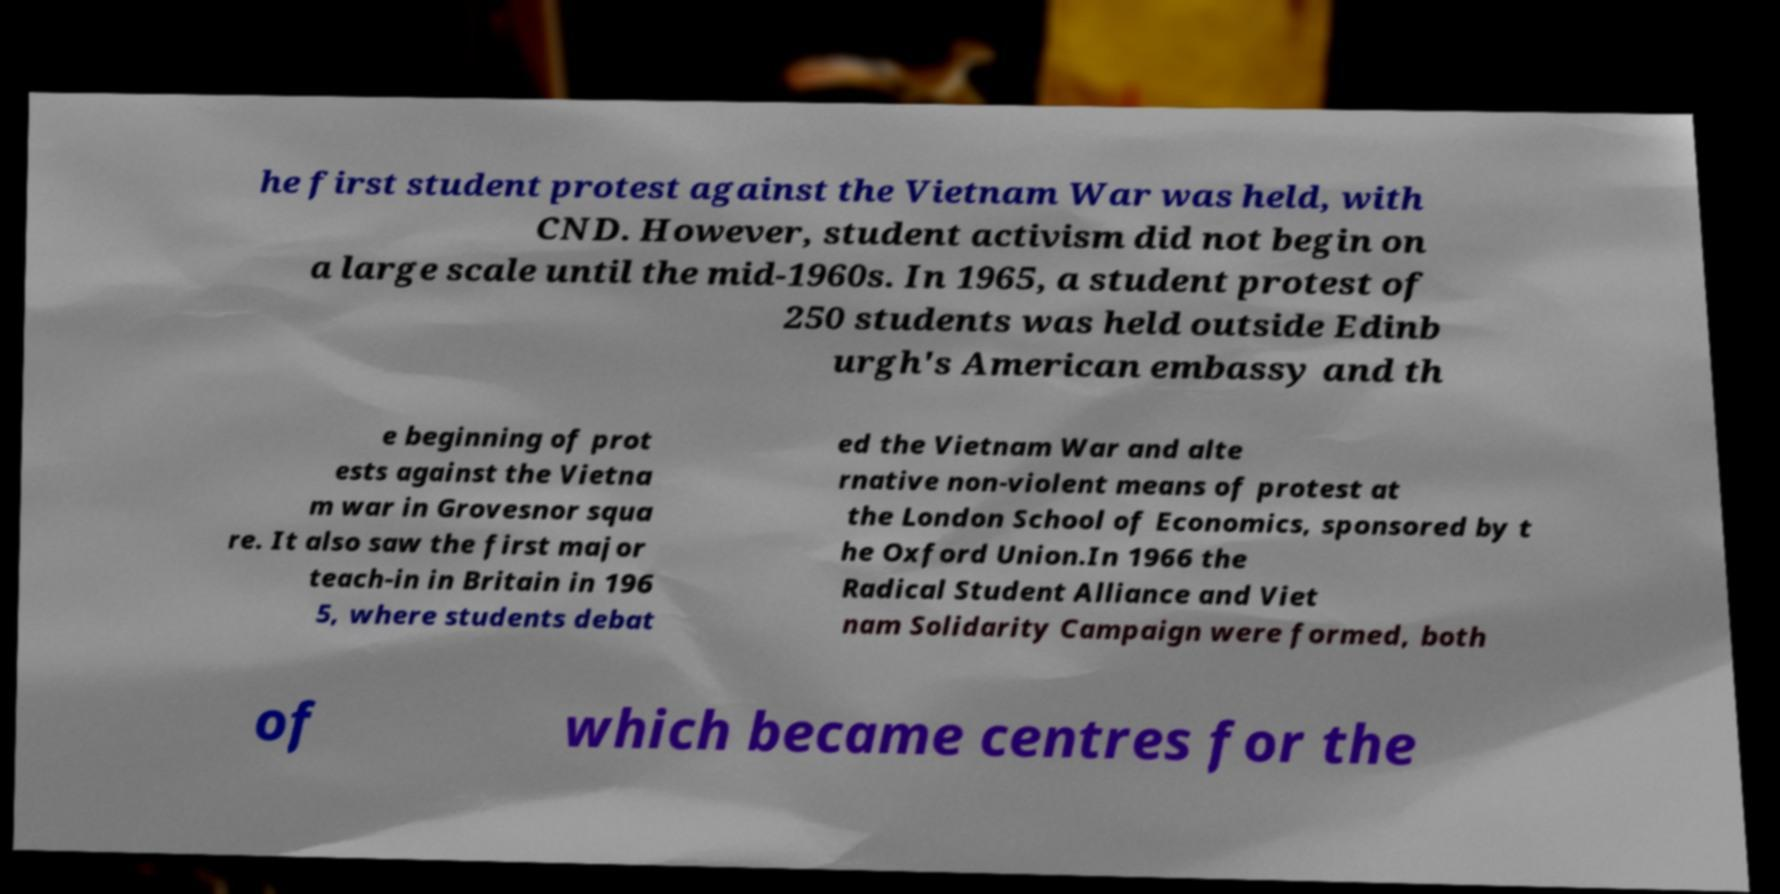What messages or text are displayed in this image? I need them in a readable, typed format. he first student protest against the Vietnam War was held, with CND. However, student activism did not begin on a large scale until the mid-1960s. In 1965, a student protest of 250 students was held outside Edinb urgh's American embassy and th e beginning of prot ests against the Vietna m war in Grovesnor squa re. It also saw the first major teach-in in Britain in 196 5, where students debat ed the Vietnam War and alte rnative non-violent means of protest at the London School of Economics, sponsored by t he Oxford Union.In 1966 the Radical Student Alliance and Viet nam Solidarity Campaign were formed, both of which became centres for the 